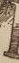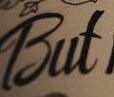Read the text content from these images in order, separated by a semicolon. #; But 